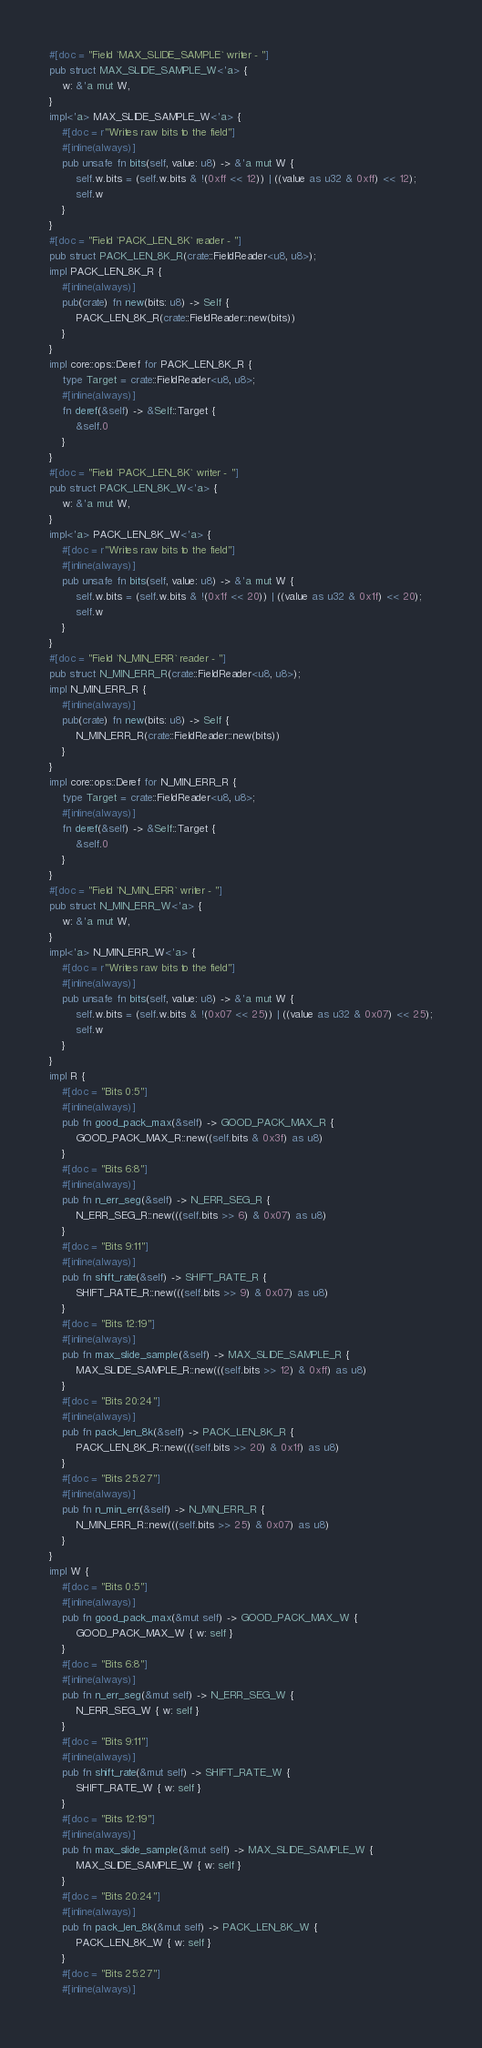<code> <loc_0><loc_0><loc_500><loc_500><_Rust_>#[doc = "Field `MAX_SLIDE_SAMPLE` writer - "]
pub struct MAX_SLIDE_SAMPLE_W<'a> {
    w: &'a mut W,
}
impl<'a> MAX_SLIDE_SAMPLE_W<'a> {
    #[doc = r"Writes raw bits to the field"]
    #[inline(always)]
    pub unsafe fn bits(self, value: u8) -> &'a mut W {
        self.w.bits = (self.w.bits & !(0xff << 12)) | ((value as u32 & 0xff) << 12);
        self.w
    }
}
#[doc = "Field `PACK_LEN_8K` reader - "]
pub struct PACK_LEN_8K_R(crate::FieldReader<u8, u8>);
impl PACK_LEN_8K_R {
    #[inline(always)]
    pub(crate) fn new(bits: u8) -> Self {
        PACK_LEN_8K_R(crate::FieldReader::new(bits))
    }
}
impl core::ops::Deref for PACK_LEN_8K_R {
    type Target = crate::FieldReader<u8, u8>;
    #[inline(always)]
    fn deref(&self) -> &Self::Target {
        &self.0
    }
}
#[doc = "Field `PACK_LEN_8K` writer - "]
pub struct PACK_LEN_8K_W<'a> {
    w: &'a mut W,
}
impl<'a> PACK_LEN_8K_W<'a> {
    #[doc = r"Writes raw bits to the field"]
    #[inline(always)]
    pub unsafe fn bits(self, value: u8) -> &'a mut W {
        self.w.bits = (self.w.bits & !(0x1f << 20)) | ((value as u32 & 0x1f) << 20);
        self.w
    }
}
#[doc = "Field `N_MIN_ERR` reader - "]
pub struct N_MIN_ERR_R(crate::FieldReader<u8, u8>);
impl N_MIN_ERR_R {
    #[inline(always)]
    pub(crate) fn new(bits: u8) -> Self {
        N_MIN_ERR_R(crate::FieldReader::new(bits))
    }
}
impl core::ops::Deref for N_MIN_ERR_R {
    type Target = crate::FieldReader<u8, u8>;
    #[inline(always)]
    fn deref(&self) -> &Self::Target {
        &self.0
    }
}
#[doc = "Field `N_MIN_ERR` writer - "]
pub struct N_MIN_ERR_W<'a> {
    w: &'a mut W,
}
impl<'a> N_MIN_ERR_W<'a> {
    #[doc = r"Writes raw bits to the field"]
    #[inline(always)]
    pub unsafe fn bits(self, value: u8) -> &'a mut W {
        self.w.bits = (self.w.bits & !(0x07 << 25)) | ((value as u32 & 0x07) << 25);
        self.w
    }
}
impl R {
    #[doc = "Bits 0:5"]
    #[inline(always)]
    pub fn good_pack_max(&self) -> GOOD_PACK_MAX_R {
        GOOD_PACK_MAX_R::new((self.bits & 0x3f) as u8)
    }
    #[doc = "Bits 6:8"]
    #[inline(always)]
    pub fn n_err_seg(&self) -> N_ERR_SEG_R {
        N_ERR_SEG_R::new(((self.bits >> 6) & 0x07) as u8)
    }
    #[doc = "Bits 9:11"]
    #[inline(always)]
    pub fn shift_rate(&self) -> SHIFT_RATE_R {
        SHIFT_RATE_R::new(((self.bits >> 9) & 0x07) as u8)
    }
    #[doc = "Bits 12:19"]
    #[inline(always)]
    pub fn max_slide_sample(&self) -> MAX_SLIDE_SAMPLE_R {
        MAX_SLIDE_SAMPLE_R::new(((self.bits >> 12) & 0xff) as u8)
    }
    #[doc = "Bits 20:24"]
    #[inline(always)]
    pub fn pack_len_8k(&self) -> PACK_LEN_8K_R {
        PACK_LEN_8K_R::new(((self.bits >> 20) & 0x1f) as u8)
    }
    #[doc = "Bits 25:27"]
    #[inline(always)]
    pub fn n_min_err(&self) -> N_MIN_ERR_R {
        N_MIN_ERR_R::new(((self.bits >> 25) & 0x07) as u8)
    }
}
impl W {
    #[doc = "Bits 0:5"]
    #[inline(always)]
    pub fn good_pack_max(&mut self) -> GOOD_PACK_MAX_W {
        GOOD_PACK_MAX_W { w: self }
    }
    #[doc = "Bits 6:8"]
    #[inline(always)]
    pub fn n_err_seg(&mut self) -> N_ERR_SEG_W {
        N_ERR_SEG_W { w: self }
    }
    #[doc = "Bits 9:11"]
    #[inline(always)]
    pub fn shift_rate(&mut self) -> SHIFT_RATE_W {
        SHIFT_RATE_W { w: self }
    }
    #[doc = "Bits 12:19"]
    #[inline(always)]
    pub fn max_slide_sample(&mut self) -> MAX_SLIDE_SAMPLE_W {
        MAX_SLIDE_SAMPLE_W { w: self }
    }
    #[doc = "Bits 20:24"]
    #[inline(always)]
    pub fn pack_len_8k(&mut self) -> PACK_LEN_8K_W {
        PACK_LEN_8K_W { w: self }
    }
    #[doc = "Bits 25:27"]
    #[inline(always)]</code> 